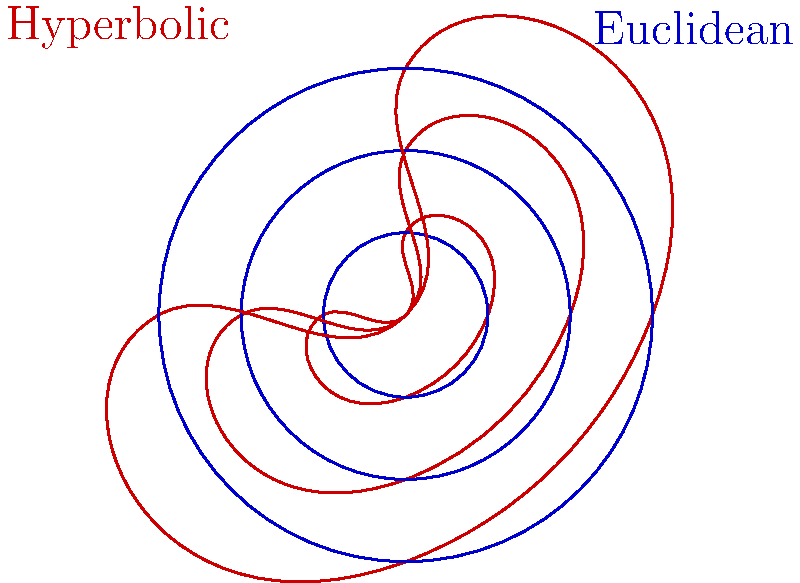As a cocktail enthusiast who appreciates the art of mixology, you understand that the balance of flavors can be affected by the shape of the glass. Similarly, in geometry, the properties of shapes can change depending on the type of space they're in. Looking at the diagram, which shows circles with increasing radii in both hyperbolic (red) and Euclidean (blue) geometries, how does the rate of increase in area compare between the two geometries as the radius increases? Let's approach this step-by-step:

1. In Euclidean geometry:
   - The area of a circle is given by $A = \pi r^2$
   - As the radius increases linearly, the area increases quadratically

2. In hyperbolic geometry:
   - The area of a circle is given by $A = 4\pi \sinh^2(\frac{r}{2})$, where $\sinh$ is the hyperbolic sine function
   - As $r$ increases, $\sinh(\frac{r}{2})$ grows exponentially

3. Comparing the growth:
   - In Euclidean geometry, doubling the radius quadruples the area
   - In hyperbolic geometry, doubling the radius more than quadruples the area

4. Visual comparison:
   - In the diagram, we see that the hyperbolic circles (red) grow in size much more rapidly than the Euclidean circles (blue) as the radius increases

5. Interpretation:
   - This means that in hyperbolic geometry, the area of a circle increases at a faster rate than in Euclidean geometry for the same increase in radius

Just as a well-crafted cocktail can surprise with its complexity, hyperbolic geometry reveals unexpected properties in familiar shapes.
Answer: The area increases more rapidly in hyperbolic geometry than in Euclidean geometry as the radius increases. 